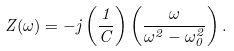<formula> <loc_0><loc_0><loc_500><loc_500>Z ( \omega ) = - j \left ( { \frac { 1 } { C } } \right ) \left ( { \frac { \omega } { \omega ^ { 2 } - \omega _ { 0 } ^ { 2 } } } \right ) .</formula> 